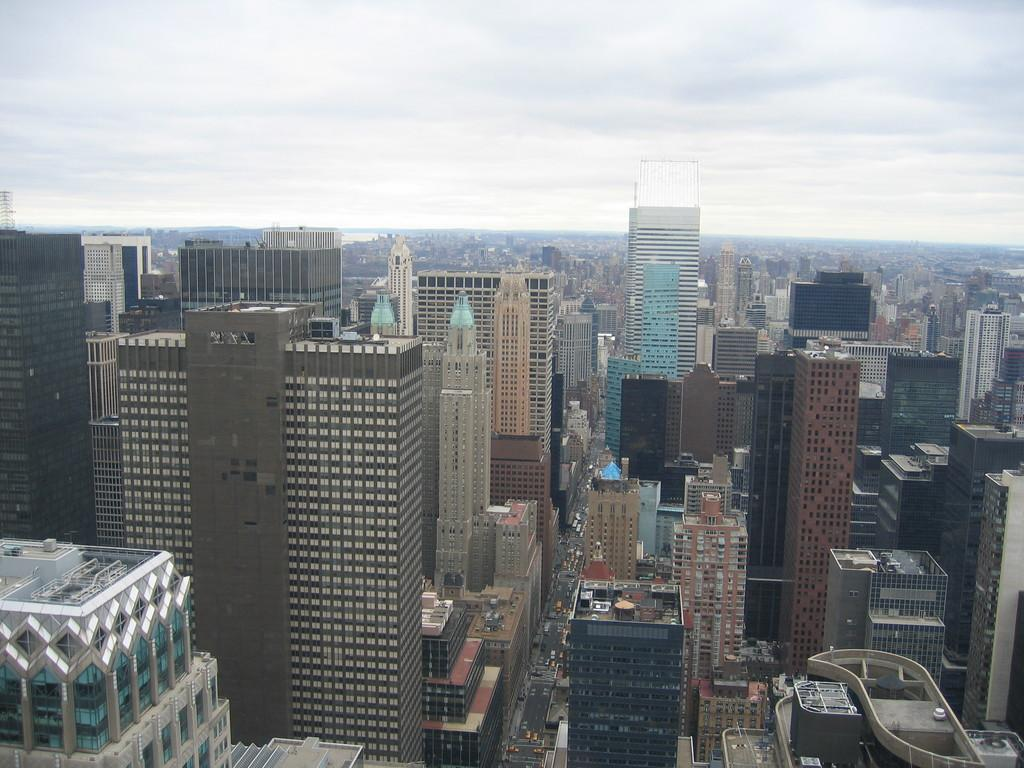What type of view is shown in the image? The image is an outside view. What structures can be seen at the bottom of the image? There are many buildings visible at the bottom of the image. What part of the natural environment is visible in the image? The sky is visible at the top of the image. What type of payment is required to enter the buildings in the image? There is no information about payment or entering the buildings in the image. 